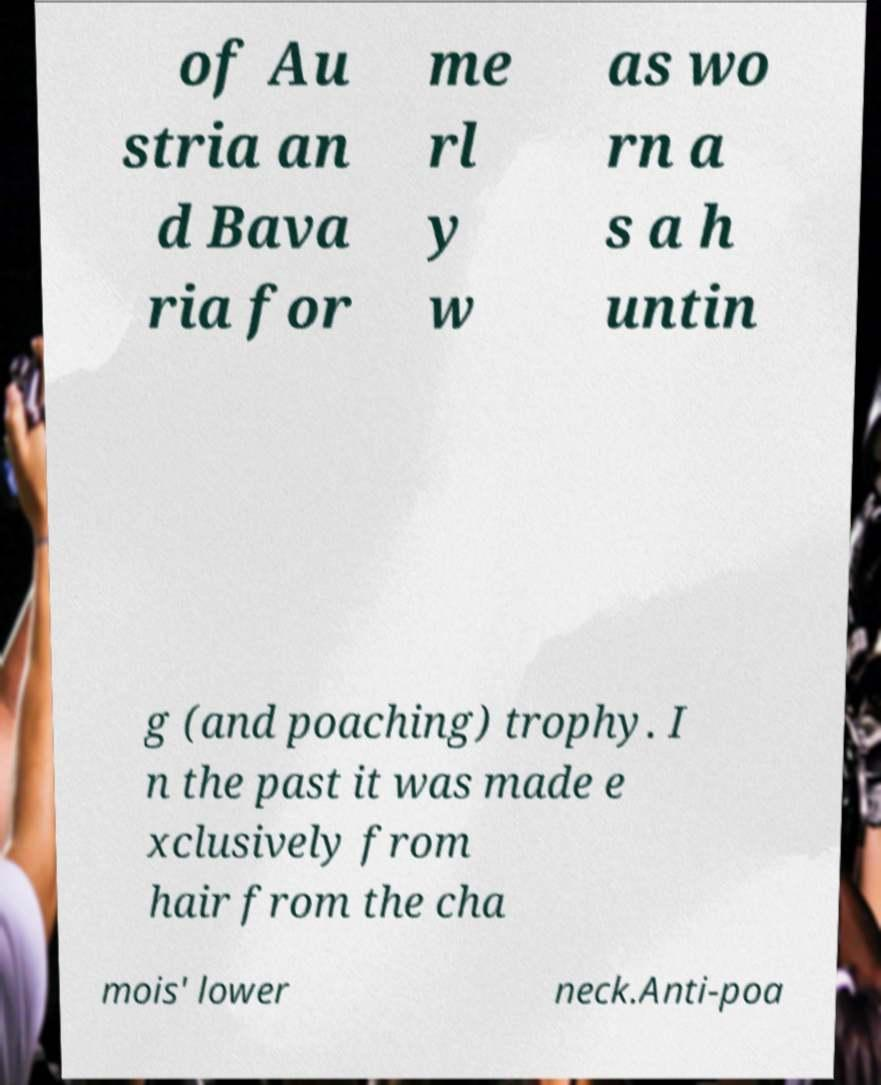Please read and relay the text visible in this image. What does it say? of Au stria an d Bava ria for me rl y w as wo rn a s a h untin g (and poaching) trophy. I n the past it was made e xclusively from hair from the cha mois' lower neck.Anti-poa 